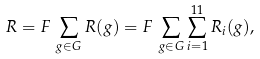Convert formula to latex. <formula><loc_0><loc_0><loc_500><loc_500>R = F \, \sum _ { g \in G } R ( g ) = F \, \sum _ { g \in G } \sum _ { i = 1 } ^ { 1 1 } R _ { i } ( g ) ,</formula> 